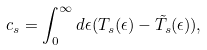<formula> <loc_0><loc_0><loc_500><loc_500>c _ { s } = \int _ { 0 } ^ { \infty } d \epsilon ( T _ { s } ( \epsilon ) - \tilde { T _ { s } } ( \epsilon ) ) ,</formula> 